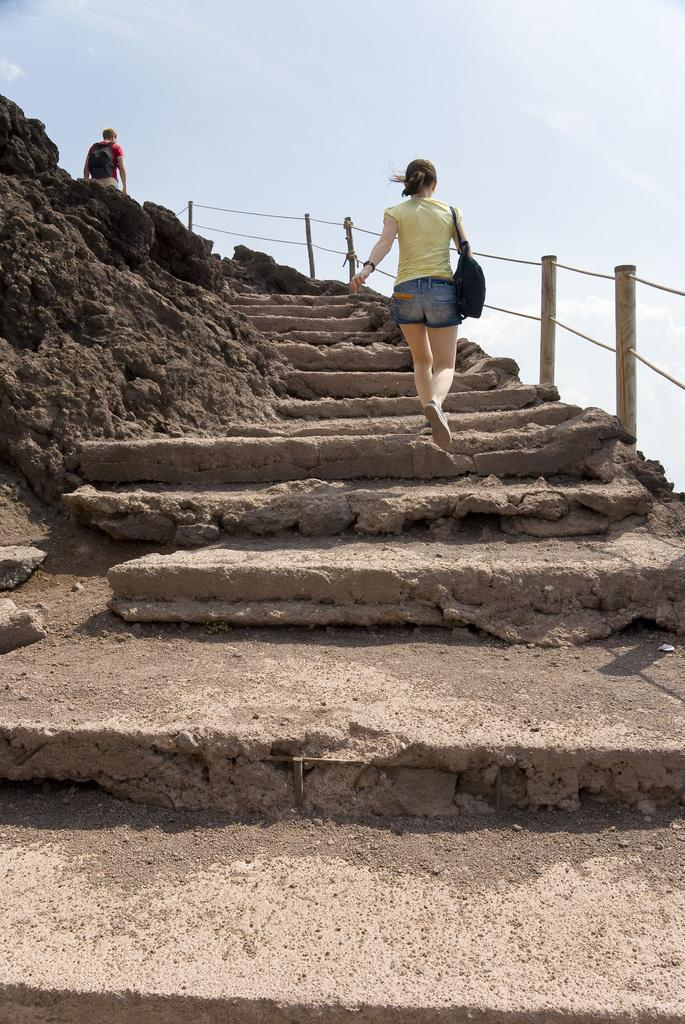What type of architectural feature is present in the image? There are stairs in the image. How many people are in the image? There are two people in the image. What are the people doing in the image? The people are carrying bags. What can be seen in the background of the image? The sky is visible in the background of the image. Can you tell me how many bees are buzzing around the people in the image? There are no bees present in the image. 